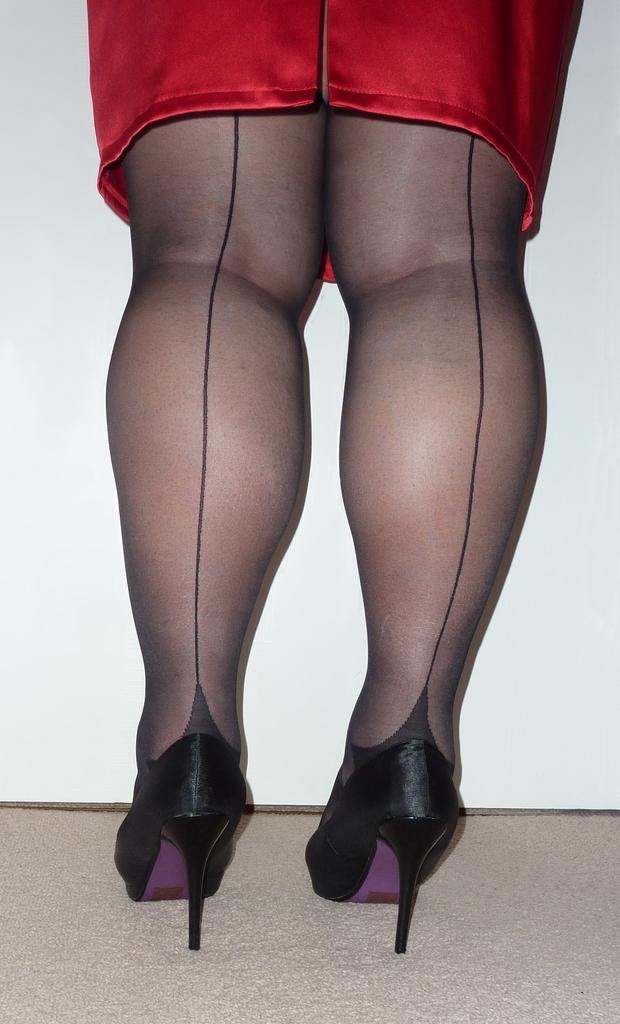Describe this image in one or two sentences. In this image the legs of the person is visible in the center. 